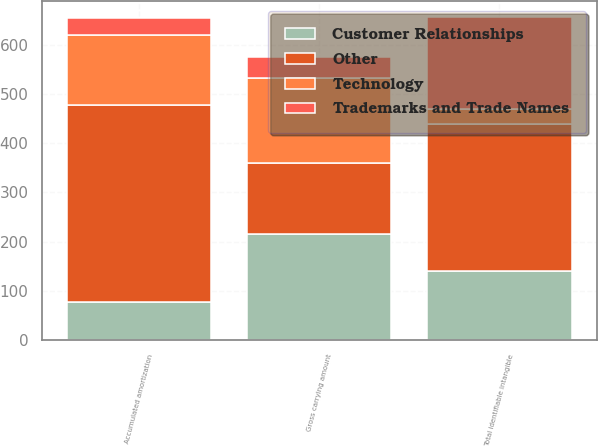<chart> <loc_0><loc_0><loc_500><loc_500><stacked_bar_chart><ecel><fcel>Gross carrying amount<fcel>Accumulated amortization<fcel>Total identifiable intangible<nl><fcel>Other<fcel>142.5<fcel>401.4<fcel>299<nl><fcel>Technology<fcel>173.4<fcel>142.5<fcel>30.9<nl><fcel>Trademarks and Trade Names<fcel>43.3<fcel>33.9<fcel>186.8<nl><fcel>Customer Relationships<fcel>216.2<fcel>76.4<fcel>139.8<nl></chart> 